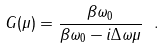Convert formula to latex. <formula><loc_0><loc_0><loc_500><loc_500>G ( \mu ) = \frac { \beta \omega _ { 0 } } { \beta \omega _ { 0 } - i \Delta \omega \mu } \ .</formula> 